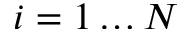Convert formula to latex. <formula><loc_0><loc_0><loc_500><loc_500>i = 1 \dots N</formula> 